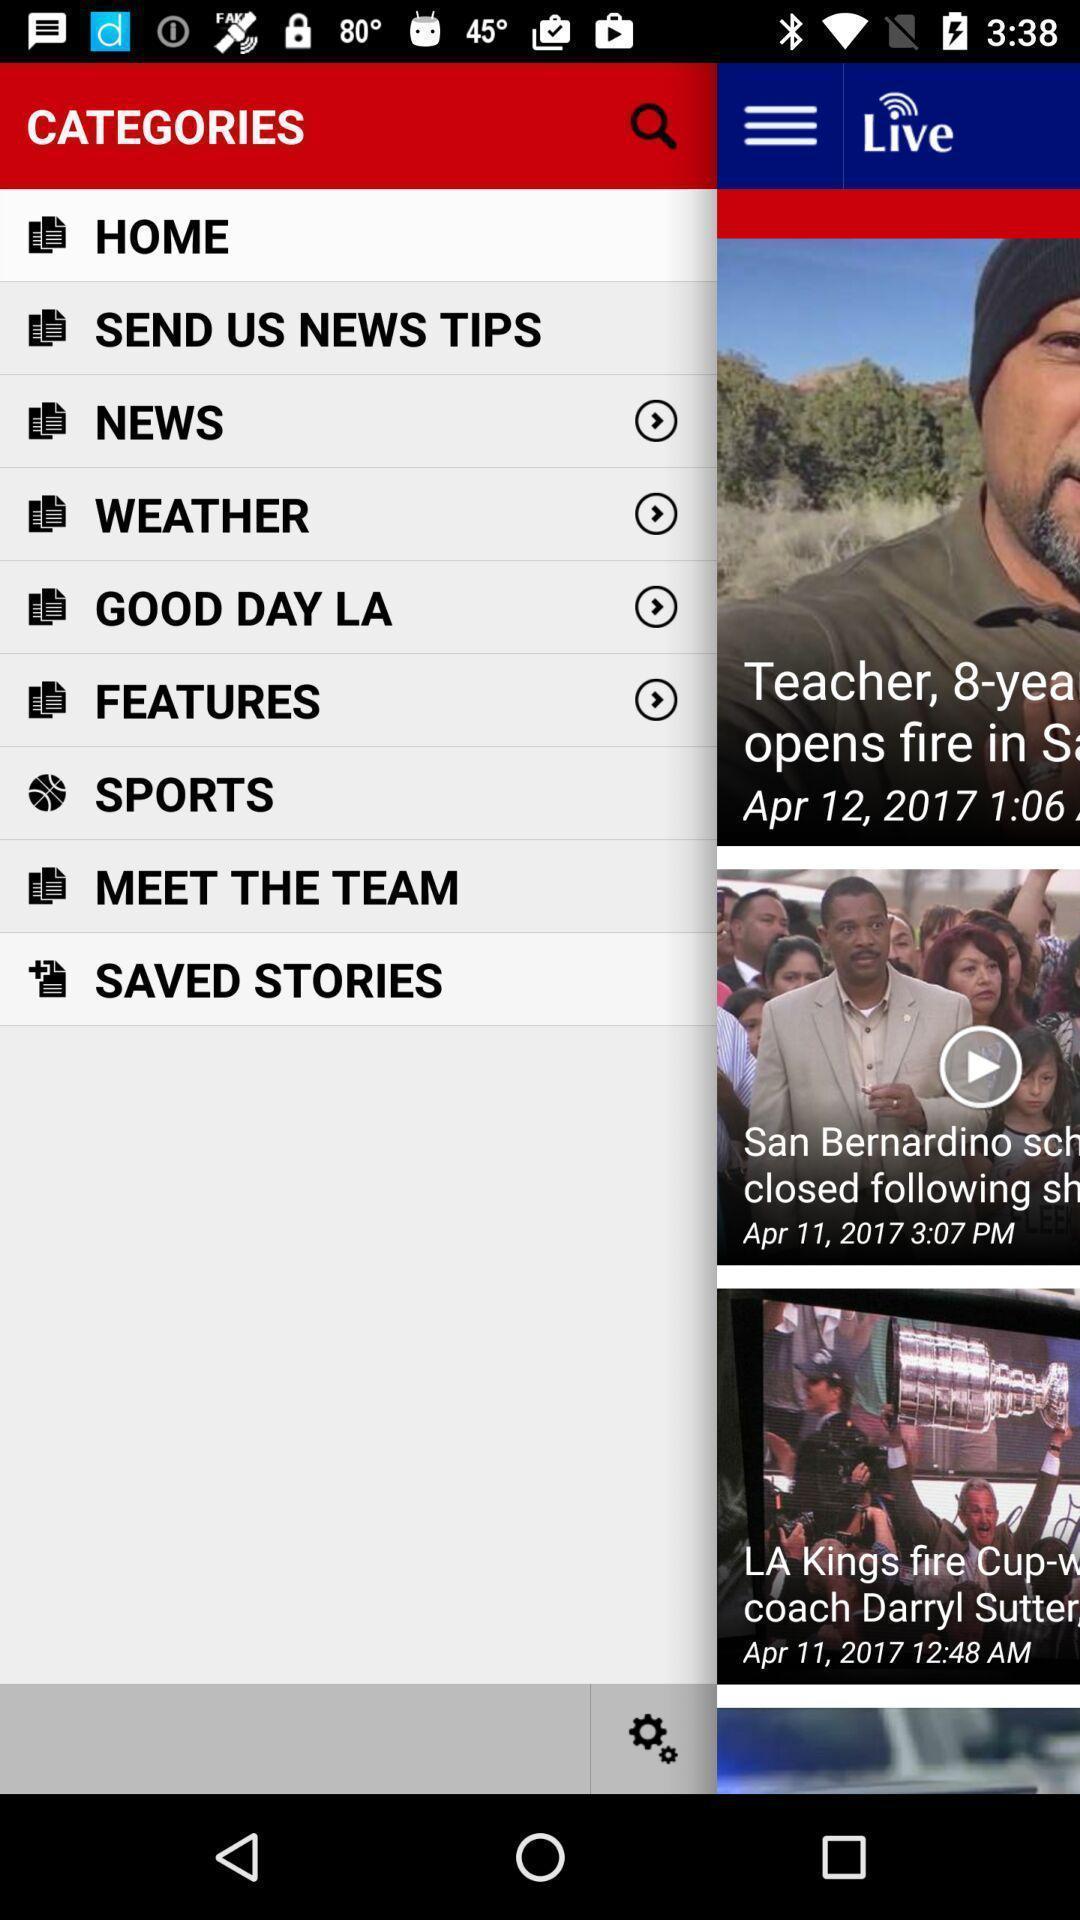Provide a description of this screenshot. Page showing list of categories. 